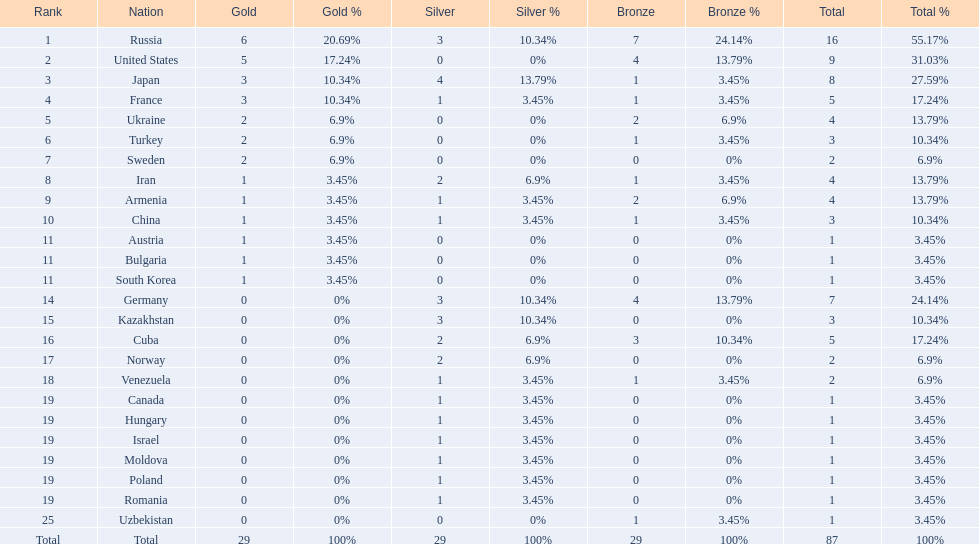Which nations are there? Russia, 6, United States, 5, Japan, 3, France, 3, Ukraine, 2, Turkey, 2, Sweden, 2, Iran, 1, Armenia, 1, China, 1, Austria, 1, Bulgaria, 1, South Korea, 1, Germany, 0, Kazakhstan, 0, Cuba, 0, Norway, 0, Venezuela, 0, Canada, 0, Hungary, 0, Israel, 0, Moldova, 0, Poland, 0, Romania, 0, Uzbekistan, 0. Which nations won gold? Russia, 6, United States, 5, Japan, 3, France, 3, Ukraine, 2, Turkey, 2, Sweden, 2, Iran, 1, Armenia, 1, China, 1, Austria, 1, Bulgaria, 1, South Korea, 1. How many golds did united states win? United States, 5. Which country has more than 5 gold medals? Russia, 6. What country is it? Russia. 